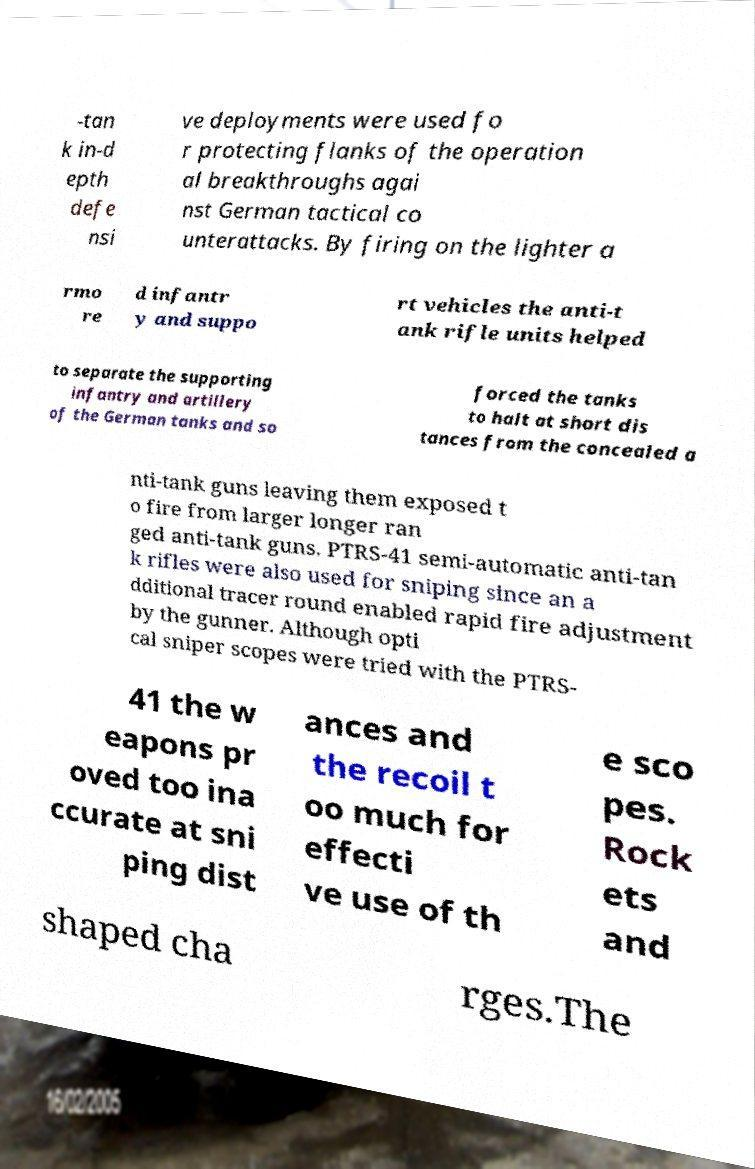Please read and relay the text visible in this image. What does it say? -tan k in-d epth defe nsi ve deployments were used fo r protecting flanks of the operation al breakthroughs agai nst German tactical co unterattacks. By firing on the lighter a rmo re d infantr y and suppo rt vehicles the anti-t ank rifle units helped to separate the supporting infantry and artillery of the German tanks and so forced the tanks to halt at short dis tances from the concealed a nti-tank guns leaving them exposed t o fire from larger longer ran ged anti-tank guns. PTRS-41 semi-automatic anti-tan k rifles were also used for sniping since an a dditional tracer round enabled rapid fire adjustment by the gunner. Although opti cal sniper scopes were tried with the PTRS- 41 the w eapons pr oved too ina ccurate at sni ping dist ances and the recoil t oo much for effecti ve use of th e sco pes. Rock ets and shaped cha rges.The 